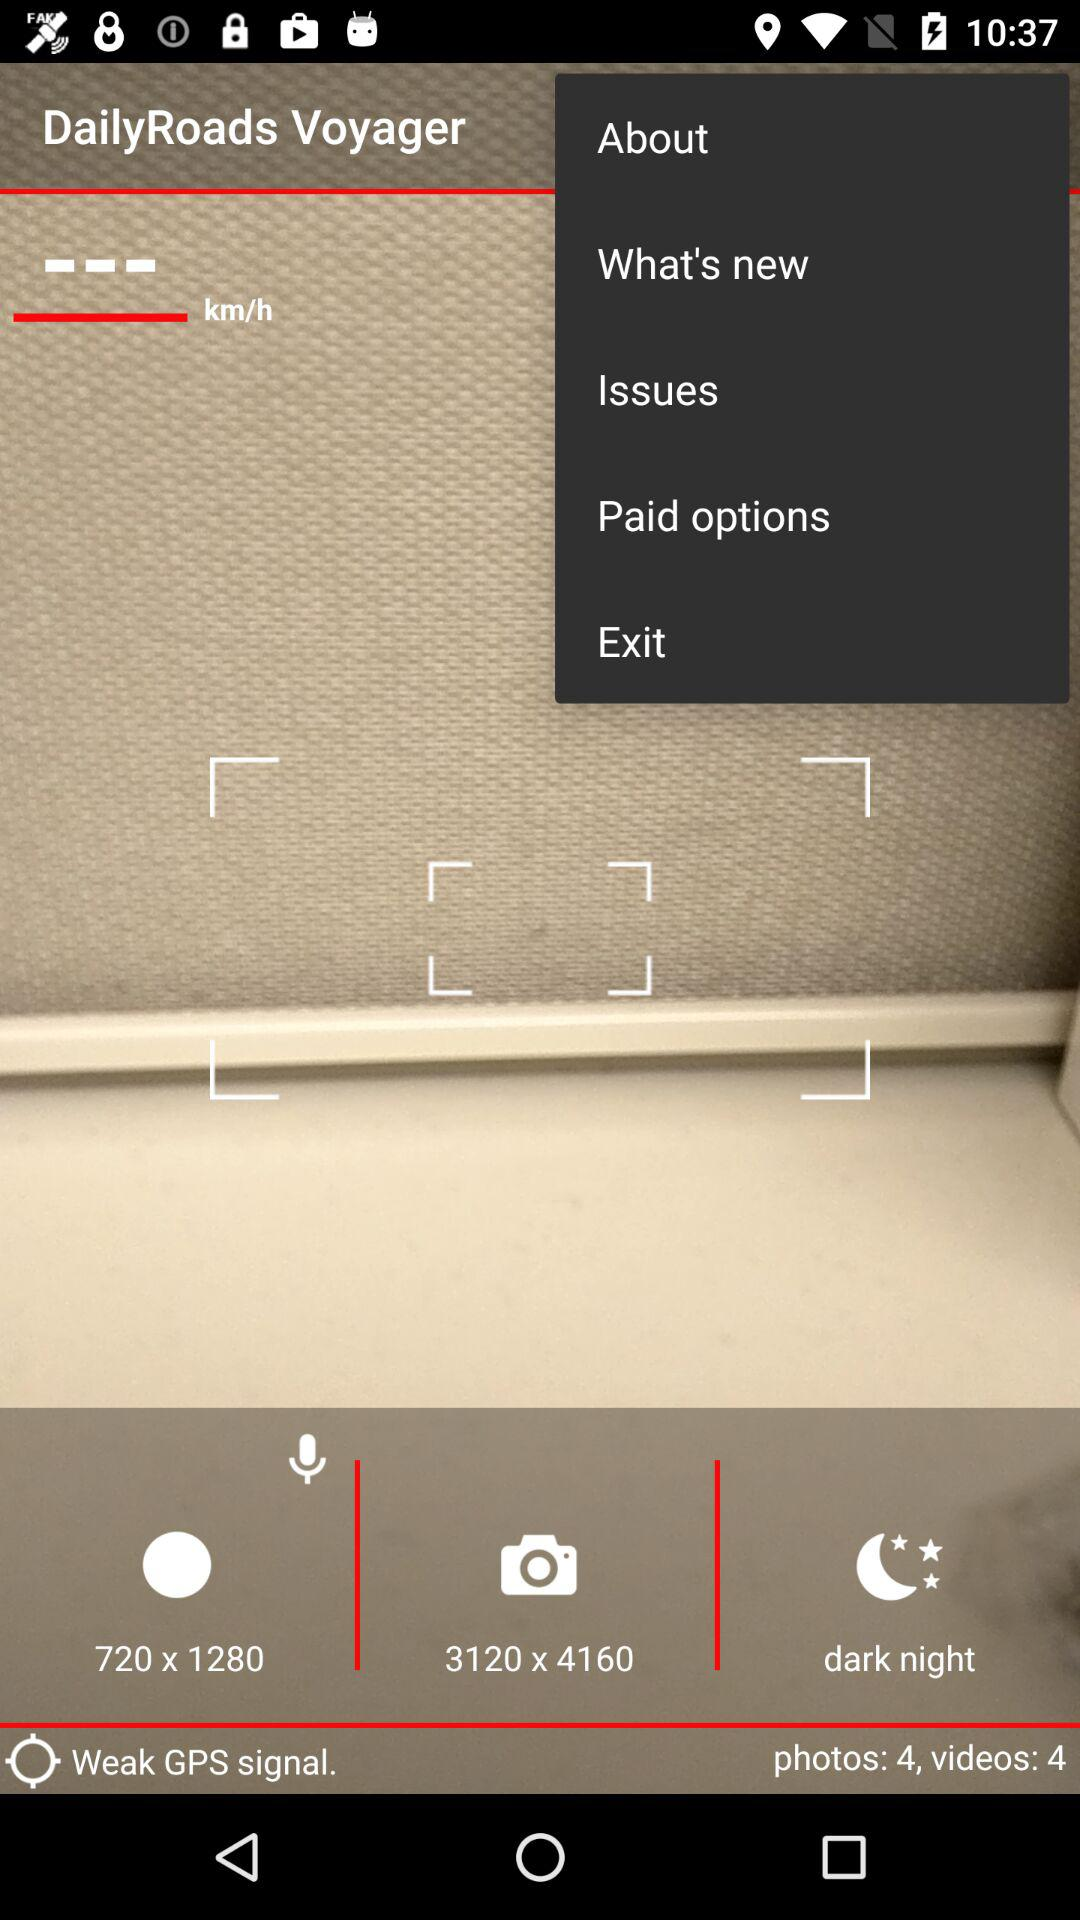What is the resolution of the camera? The resolution of the camera is 3120 × 4160. 